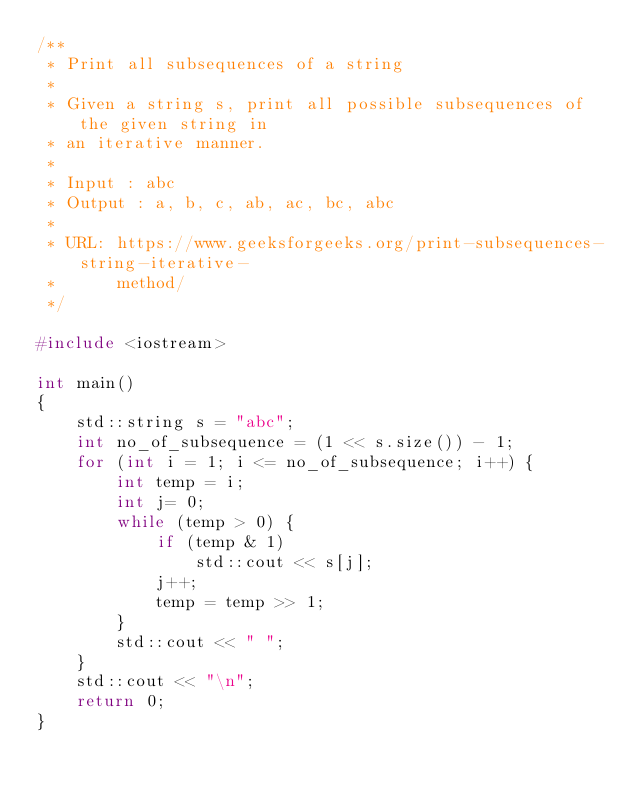<code> <loc_0><loc_0><loc_500><loc_500><_C++_>/**
 * Print all subsequences of a string
 *
 * Given a string s, print all possible subsequences of the given string in
 * an iterative manner.
 *
 * Input : abc
 * Output : a, b, c, ab, ac, bc, abc
 *
 * URL: https://www.geeksforgeeks.org/print-subsequences-string-iterative-
 *      method/
 */

#include <iostream>

int main()
{
    std::string s = "abc";
    int no_of_subsequence = (1 << s.size()) - 1;
    for (int i = 1; i <= no_of_subsequence; i++) {
        int temp = i;
        int j= 0;
        while (temp > 0) {
            if (temp & 1)
                std::cout << s[j];
            j++;
            temp = temp >> 1;
        }
        std::cout << " ";
    }
    std::cout << "\n";
    return 0;
}
</code> 